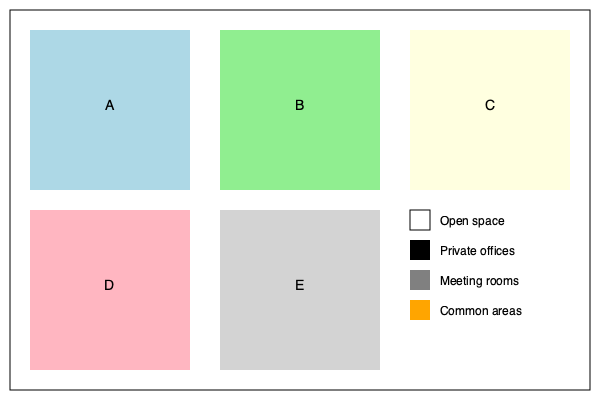Based on current market trends for multi-story office buildings in Spain, which floor plan layout option (A, B, C, D, or E) would be most optimal for maximizing rental value and tenant satisfaction? To determine the optimal floor plan layout, we need to consider several factors based on current market trends in Spain:

1. Flexibility: Modern office spaces need to adapt to changing work styles.
2. Collaboration: Open spaces for teamwork are increasingly important.
3. Privacy: Some private areas are still necessary for focused work and confidential meetings.
4. Work-life balance: Common areas contribute to employee well-being.
5. Space efficiency: Maximizing usable space increases rental value.

Analyzing each option:

A: Mostly open space with few private areas. Lacks balance and meeting rooms.
B: Good mix of open space and private offices, but limited common areas.
C: Too many private offices, not aligned with current collaborative work trends.
D: Excessive common areas, reducing rentable space and productivity.
E: Optimal balance of all elements:
   - Large open space for collaboration (≈50%)
   - Adequate private offices for focused work (≈20%)
   - Sufficient meeting rooms for team discussions (≈15%)
   - Well-proportioned common areas for work-life balance (≈15%)

Option E provides the best layout to maximize rental value by efficient space use and increase tenant satisfaction through a balanced environment catering to various work needs.
Answer: Option E 